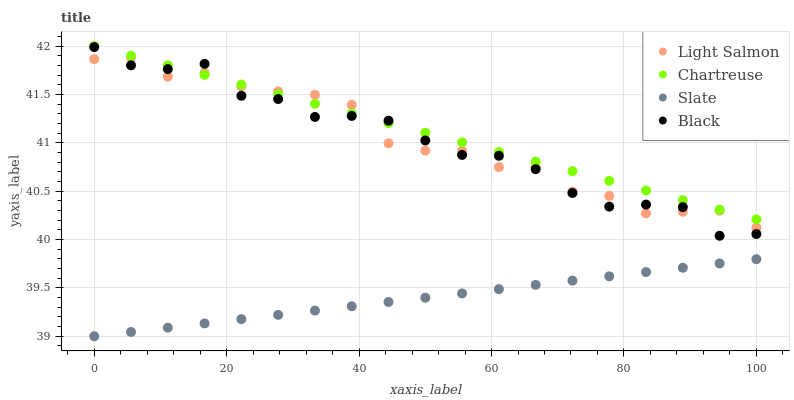Does Slate have the minimum area under the curve?
Answer yes or no. Yes. Does Chartreuse have the maximum area under the curve?
Answer yes or no. Yes. Does Black have the minimum area under the curve?
Answer yes or no. No. Does Black have the maximum area under the curve?
Answer yes or no. No. Is Chartreuse the smoothest?
Answer yes or no. Yes. Is Black the roughest?
Answer yes or no. Yes. Is Slate the smoothest?
Answer yes or no. No. Is Slate the roughest?
Answer yes or no. No. Does Slate have the lowest value?
Answer yes or no. Yes. Does Black have the lowest value?
Answer yes or no. No. Does Chartreuse have the highest value?
Answer yes or no. Yes. Does Black have the highest value?
Answer yes or no. No. Is Slate less than Chartreuse?
Answer yes or no. Yes. Is Light Salmon greater than Slate?
Answer yes or no. Yes. Does Light Salmon intersect Chartreuse?
Answer yes or no. Yes. Is Light Salmon less than Chartreuse?
Answer yes or no. No. Is Light Salmon greater than Chartreuse?
Answer yes or no. No. Does Slate intersect Chartreuse?
Answer yes or no. No. 